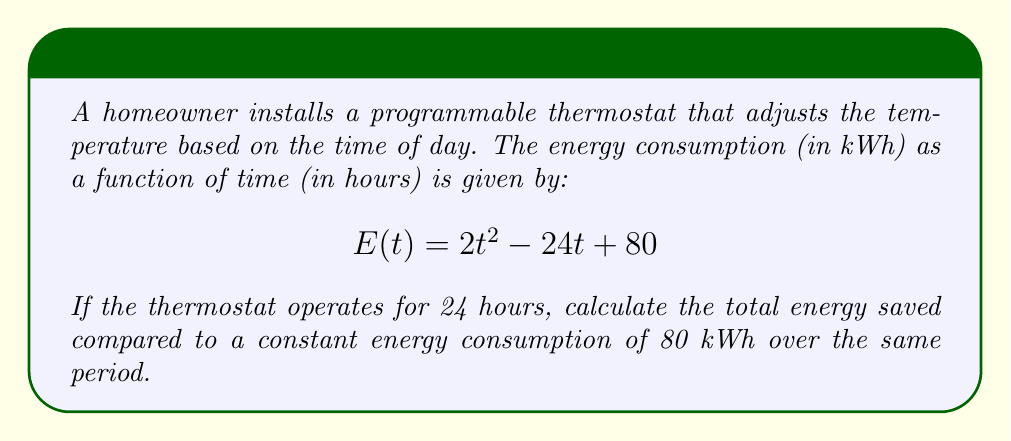Give your solution to this math problem. To solve this problem, we'll follow these steps:

1) First, we need to find the total energy consumed with the programmable thermostat over 24 hours. This can be done by integrating the function $E(t)$ from 0 to 24:

   $$\int_0^{24} E(t) dt = \int_0^{24} (2t^2 - 24t + 80) dt$$

2) Integrate the function:

   $$\left[\frac{2t^3}{3} - 12t^2 + 80t\right]_0^{24}$$

3) Evaluate the integral:

   $$\left(\frac{2(24^3)}{3} - 12(24^2) + 80(24)\right) - \left(\frac{2(0^3)}{3} - 12(0^2) + 80(0)\right)$$

   $$= (9216 - 6912 + 1920) - 0 = 4224$$

4) The total energy consumed with the programmable thermostat is 4224 kWh.

5) The constant energy consumption over 24 hours would be:

   $$80 \text{ kWh} \times 24 \text{ hours} = 1920 \text{ kWh}$$

6) The energy saved is the difference between the constant consumption and the actual consumption:

   $$1920 \text{ kWh} - 4224 \text{ kWh} = -2304 \text{ kWh}$$

The negative value indicates that the programmable thermostat actually consumed more energy in this scenario.
Answer: -2304 kWh 